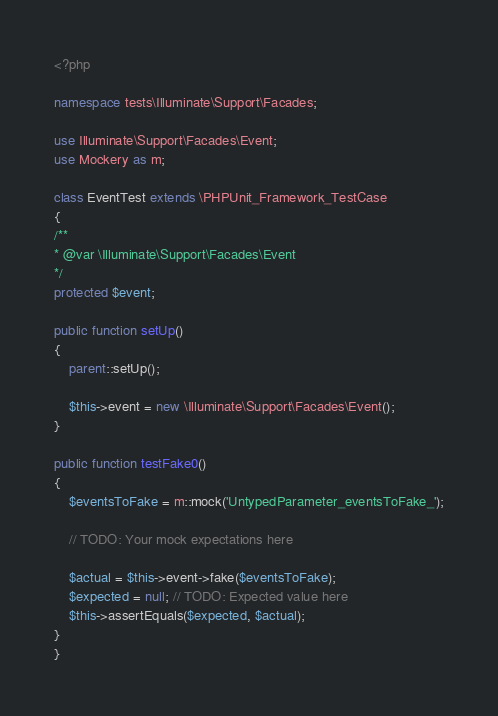<code> <loc_0><loc_0><loc_500><loc_500><_PHP_><?php

namespace tests\Illuminate\Support\Facades;

use Illuminate\Support\Facades\Event;
use Mockery as m;

class EventTest extends \PHPUnit_Framework_TestCase
{
/**
* @var \Illuminate\Support\Facades\Event
*/
protected $event;

public function setUp()
{
    parent::setUp();

    $this->event = new \Illuminate\Support\Facades\Event();
}

public function testFake0()
{
    $eventsToFake = m::mock('UntypedParameter_eventsToFake_');

    // TODO: Your mock expectations here

    $actual = $this->event->fake($eventsToFake);
    $expected = null; // TODO: Expected value here
    $this->assertEquals($expected, $actual);
}
}
</code> 